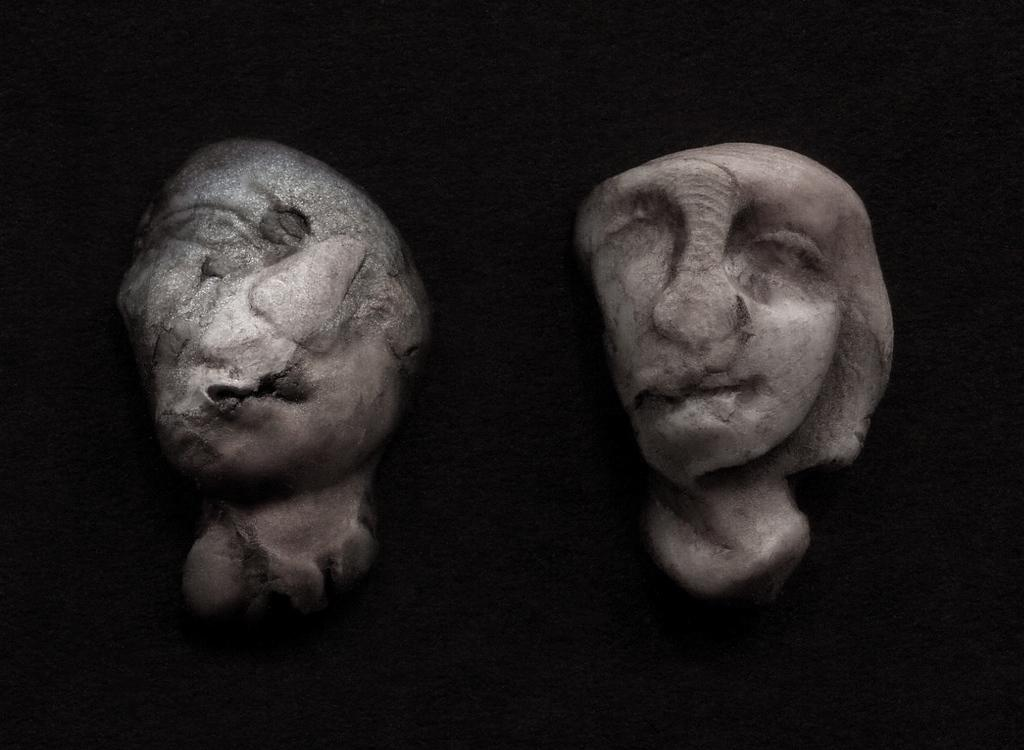What type of art is featured in the image? There are sculptures in the image. What can be observed about the lighting or color scheme in the image? The background of the image is dark. What type of fruit is being used to draw on the sculptures in the image? There is no fruit, such as quince, or any drawing tools, like crayons, present in the image. Additionally, there are no fish depicted in the image. 